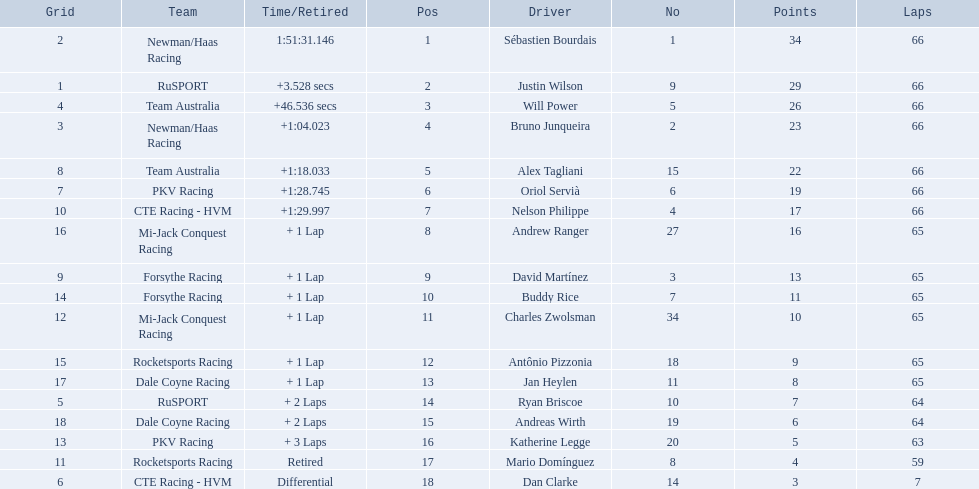What are the drivers numbers? 1, 9, 5, 2, 15, 6, 4, 27, 3, 7, 34, 18, 11, 10, 19, 20, 8, 14. Are there any who's number matches his position? Sébastien Bourdais, Oriol Servià. Of those two who has the highest position? Sébastien Bourdais. 